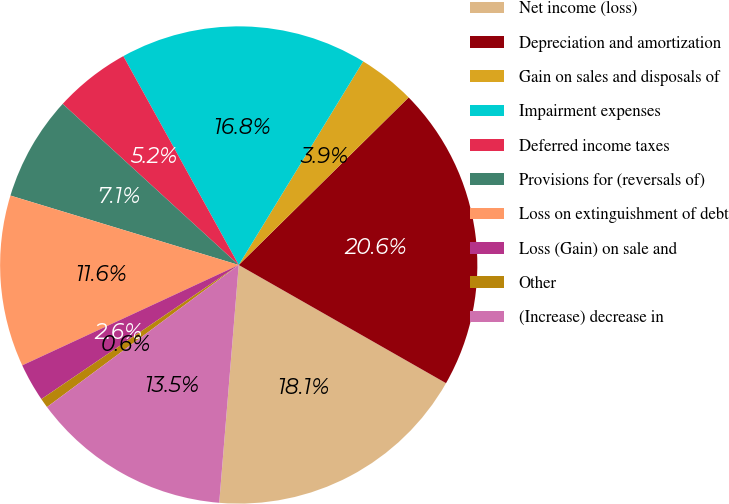Convert chart to OTSL. <chart><loc_0><loc_0><loc_500><loc_500><pie_chart><fcel>Net income (loss)<fcel>Depreciation and amortization<fcel>Gain on sales and disposals of<fcel>Impairment expenses<fcel>Deferred income taxes<fcel>Provisions for (reversals of)<fcel>Loss on extinguishment of debt<fcel>Loss (Gain) on sale and<fcel>Other<fcel>(Increase) decrease in<nl><fcel>18.06%<fcel>20.64%<fcel>3.88%<fcel>16.77%<fcel>5.17%<fcel>7.1%<fcel>11.61%<fcel>2.59%<fcel>0.65%<fcel>13.55%<nl></chart> 